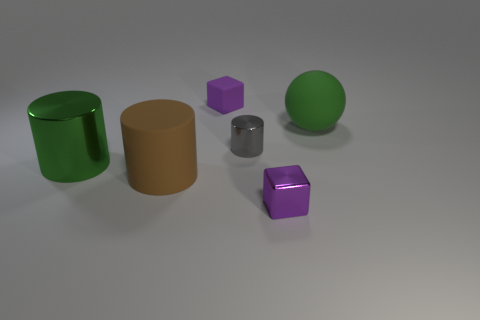Subtract all purple cylinders. Subtract all yellow balls. How many cylinders are left? 3 Add 1 large things. How many objects exist? 7 Subtract all blocks. How many objects are left? 4 Subtract all small green rubber balls. Subtract all rubber cubes. How many objects are left? 5 Add 2 big matte objects. How many big matte objects are left? 4 Add 5 purple cubes. How many purple cubes exist? 7 Subtract 0 yellow blocks. How many objects are left? 6 